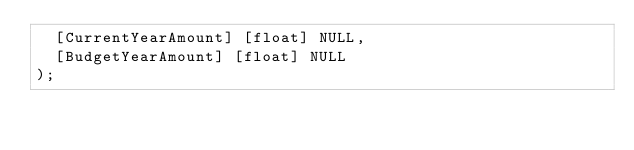<code> <loc_0><loc_0><loc_500><loc_500><_SQL_>	[CurrentYearAmount] [float] NULL,
	[BudgetYearAmount] [float] NULL
);

</code> 